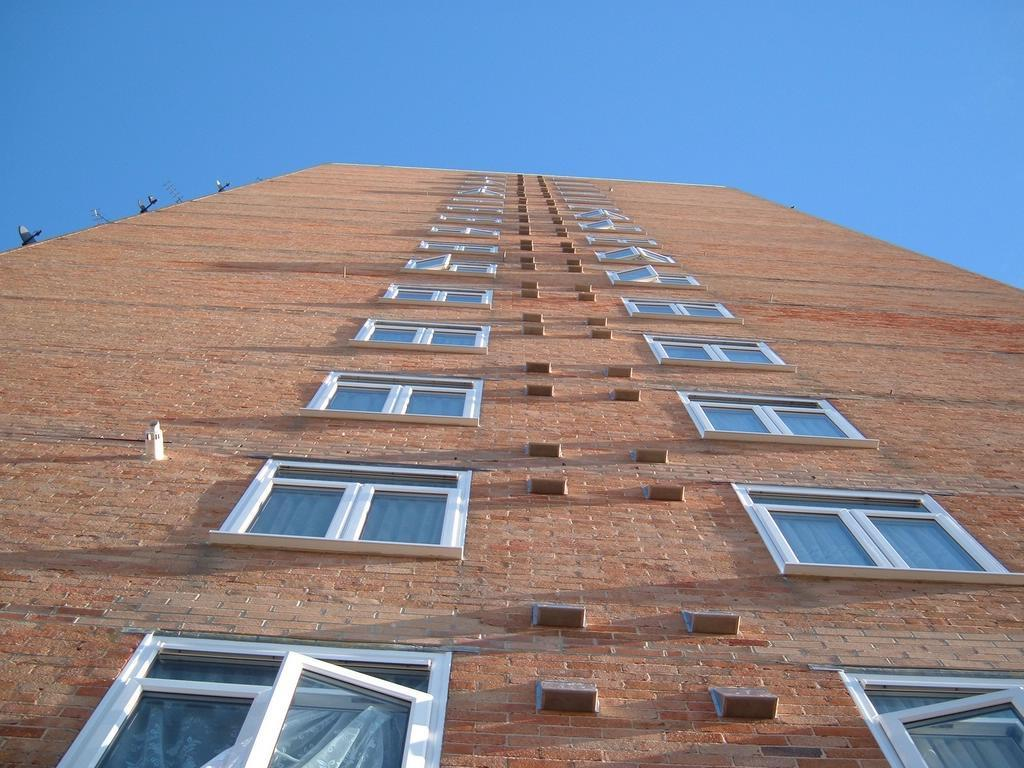What type of building is shown in the image? There is a brown color brick building in the image. What material is used for the windows of the building? The building has glass windows. What color is the sky in the image? The sky is blue in the image. What is the weight of the bird flying in the image? There is no bird present in the image, so it is not possible to determine its weight. 